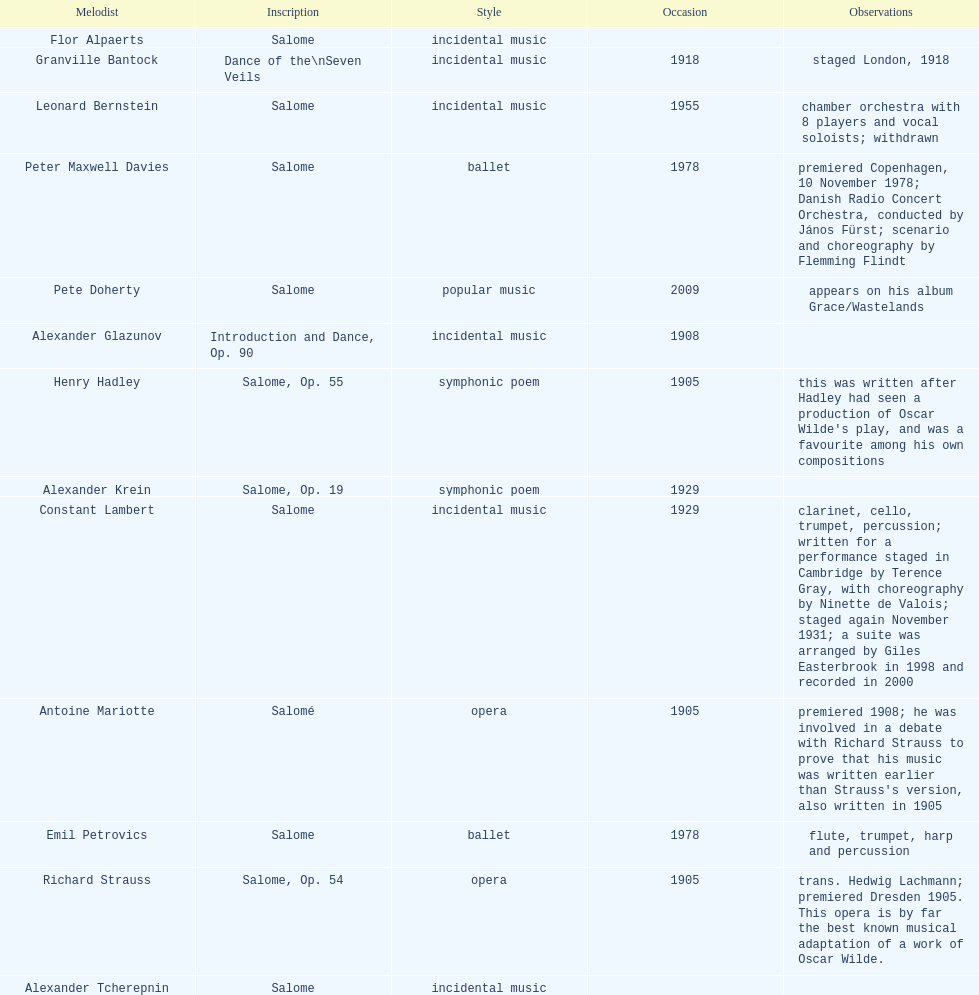Who is next on the list after alexander krein? Constant Lambert. Could you parse the entire table? {'header': ['Melodist', 'Inscription', 'Style', 'Occasion', 'Observations'], 'rows': [['Flor Alpaerts', 'Salome', 'incidental\xa0music', '', ''], ['Granville Bantock', 'Dance of the\\nSeven Veils', 'incidental music', '1918', 'staged London, 1918'], ['Leonard Bernstein', 'Salome', 'incidental music', '1955', 'chamber orchestra with 8 players and vocal soloists; withdrawn'], ['Peter\xa0Maxwell\xa0Davies', 'Salome', 'ballet', '1978', 'premiered Copenhagen, 10 November 1978; Danish Radio Concert Orchestra, conducted by János Fürst; scenario and choreography by Flemming Flindt'], ['Pete Doherty', 'Salome', 'popular music', '2009', 'appears on his album Grace/Wastelands'], ['Alexander Glazunov', 'Introduction and Dance, Op. 90', 'incidental music', '1908', ''], ['Henry Hadley', 'Salome, Op. 55', 'symphonic poem', '1905', "this was written after Hadley had seen a production of Oscar Wilde's play, and was a favourite among his own compositions"], ['Alexander Krein', 'Salome, Op. 19', 'symphonic poem', '1929', ''], ['Constant Lambert', 'Salome', 'incidental music', '1929', 'clarinet, cello, trumpet, percussion; written for a performance staged in Cambridge by Terence Gray, with choreography by Ninette de Valois; staged again November 1931; a suite was arranged by Giles Easterbrook in 1998 and recorded in 2000'], ['Antoine Mariotte', 'Salomé', 'opera', '1905', "premiered 1908; he was involved in a debate with Richard Strauss to prove that his music was written earlier than Strauss's version, also written in 1905"], ['Emil Petrovics', 'Salome', 'ballet', '1978', 'flute, trumpet, harp and percussion'], ['Richard Strauss', 'Salome, Op. 54', 'opera', '1905', 'trans. Hedwig Lachmann; premiered Dresden 1905. This opera is by far the best known musical adaptation of a work of Oscar Wilde.'], ['Alexander\xa0Tcherepnin', 'Salome', 'incidental music', '', '']]} 